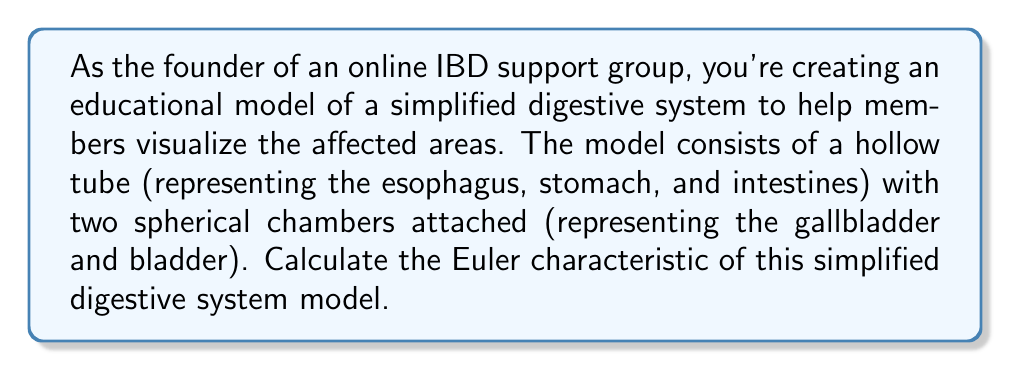Help me with this question. To calculate the Euler characteristic of this simplified digestive system model, we need to consider the topological properties of the structure. The Euler characteristic (χ) is defined as:

$$χ = V - E + F$$

Where:
$V$ = number of vertices
$E$ = number of edges
$F$ = number of faces

Let's break down our model:

1. The hollow tube (esophagus, stomach, and intestines):
   - Topologically, this is equivalent to a cylinder
   - A cylinder has no vertices, no edges, and 2 faces (the outer surface and the inner surface)

2. Two spherical chambers (gallbladder and bladder):
   - Each sphere is attached to the main tube
   - A sphere has no vertices, no edges, and 2 faces (outer and inner surfaces)
   - However, where each sphere connects to the tube, we lose one face from the sphere and one from the tube

So, let's calculate:

Vertices: $V = 0$ (no distinct vertices in this smooth model)
Edges: $E = 0$ (no distinct edges in this smooth model)
Faces: 
   - Tube: 2 faces
   - Two spheres: $2 * 2 = 4$ faces
   - Connections: We lose 2 faces where the spheres connect
   - Total faces: $F = 2 + 4 - 2 = 4$

Now we can apply the Euler characteristic formula:

$$χ = V - E + F = 0 - 0 + 4 = 4$$

Therefore, the Euler characteristic of this simplified digestive system model is 4.
Answer: $χ = 4$ 